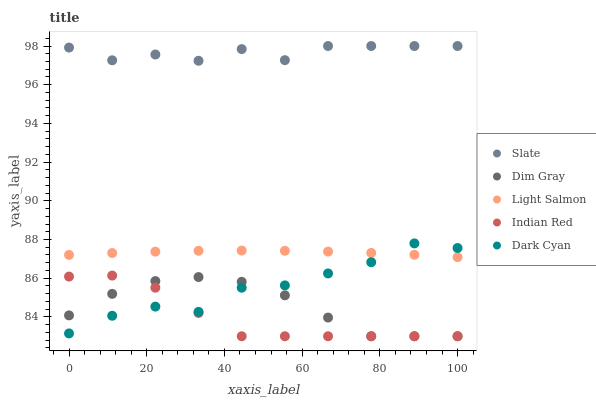Does Indian Red have the minimum area under the curve?
Answer yes or no. Yes. Does Slate have the maximum area under the curve?
Answer yes or no. Yes. Does Dim Gray have the minimum area under the curve?
Answer yes or no. No. Does Dim Gray have the maximum area under the curve?
Answer yes or no. No. Is Light Salmon the smoothest?
Answer yes or no. Yes. Is Dark Cyan the roughest?
Answer yes or no. Yes. Is Slate the smoothest?
Answer yes or no. No. Is Slate the roughest?
Answer yes or no. No. Does Dim Gray have the lowest value?
Answer yes or no. Yes. Does Slate have the lowest value?
Answer yes or no. No. Does Slate have the highest value?
Answer yes or no. Yes. Does Dim Gray have the highest value?
Answer yes or no. No. Is Dark Cyan less than Slate?
Answer yes or no. Yes. Is Light Salmon greater than Dim Gray?
Answer yes or no. Yes. Does Light Salmon intersect Dark Cyan?
Answer yes or no. Yes. Is Light Salmon less than Dark Cyan?
Answer yes or no. No. Is Light Salmon greater than Dark Cyan?
Answer yes or no. No. Does Dark Cyan intersect Slate?
Answer yes or no. No. 